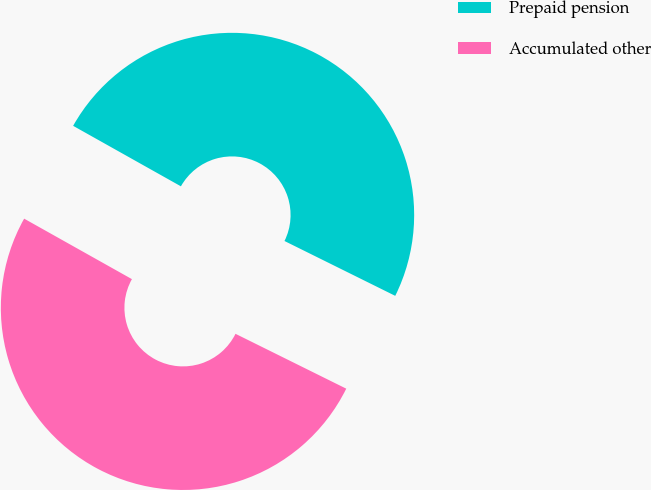Convert chart to OTSL. <chart><loc_0><loc_0><loc_500><loc_500><pie_chart><fcel>Prepaid pension<fcel>Accumulated other<nl><fcel>49.18%<fcel>50.82%<nl></chart> 